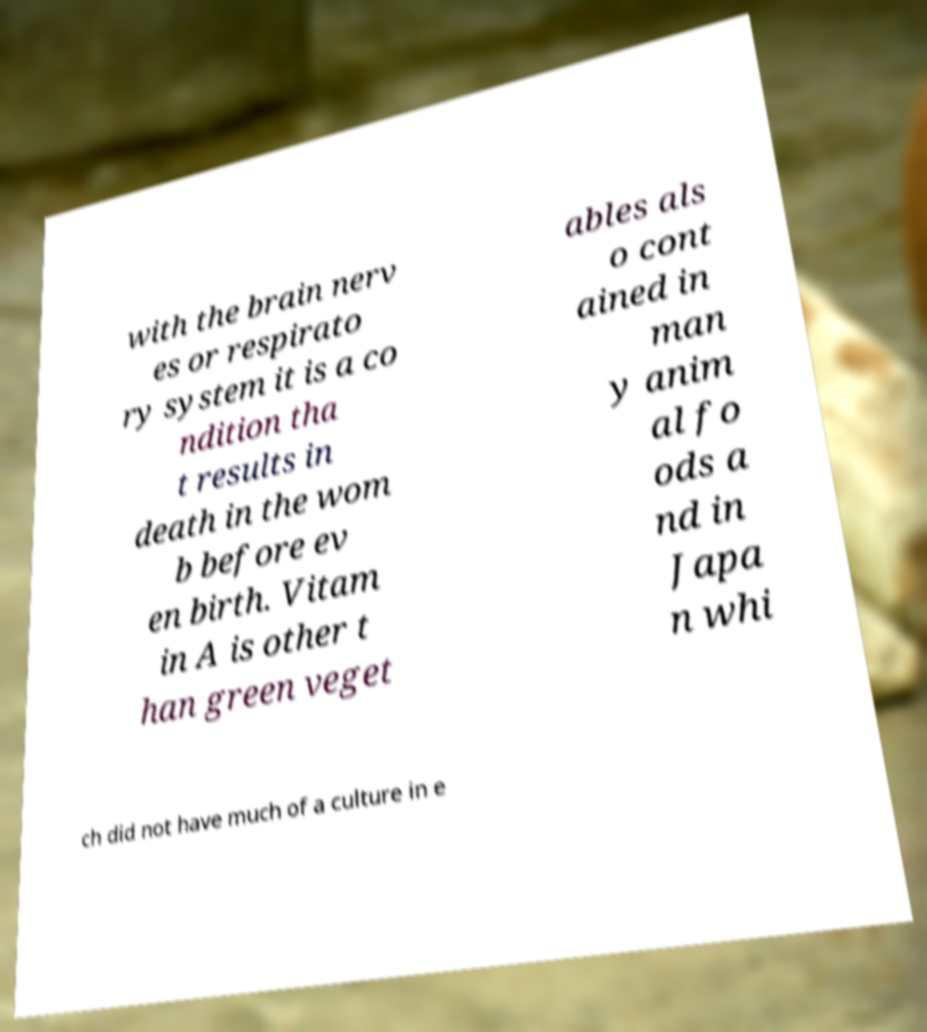I need the written content from this picture converted into text. Can you do that? with the brain nerv es or respirato ry system it is a co ndition tha t results in death in the wom b before ev en birth. Vitam in A is other t han green veget ables als o cont ained in man y anim al fo ods a nd in Japa n whi ch did not have much of a culture in e 